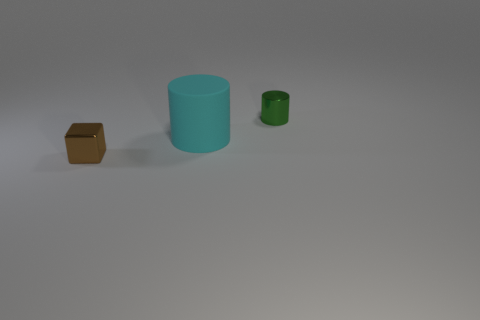Add 3 tiny yellow shiny cylinders. How many objects exist? 6 Subtract all cylinders. How many objects are left? 1 Add 1 small cylinders. How many small cylinders are left? 2 Add 2 green things. How many green things exist? 3 Subtract 0 red cylinders. How many objects are left? 3 Subtract all small metallic cylinders. Subtract all small brown cubes. How many objects are left? 1 